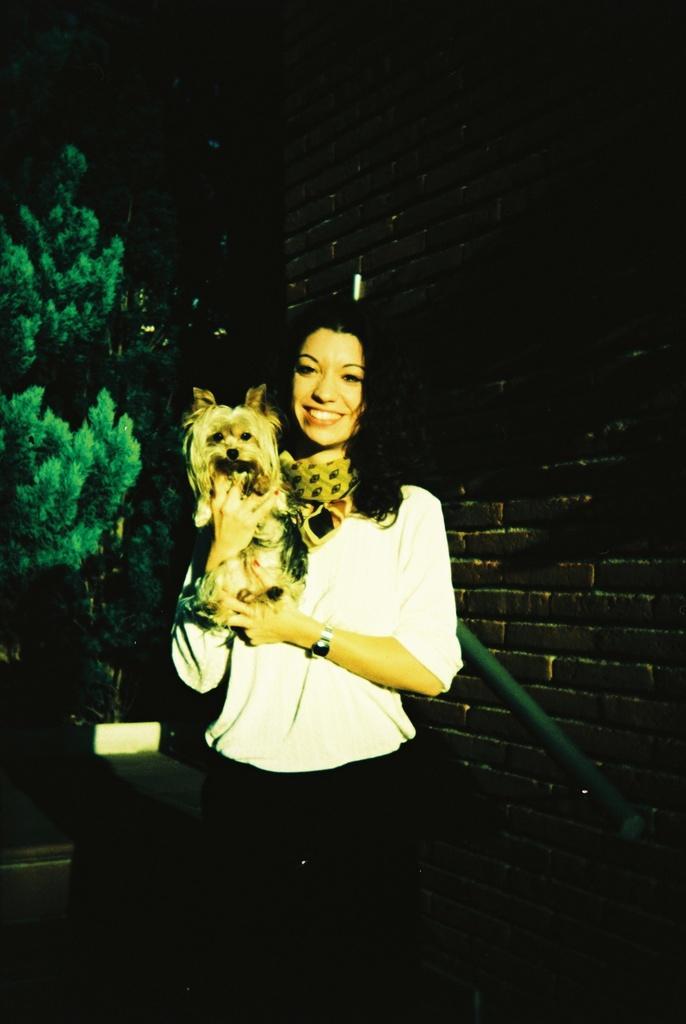Could you give a brief overview of what you see in this image? In this image, There is a woman standing and she is holding a dog, In the background there is a black color brick wall and there are some trees which are in green color. 